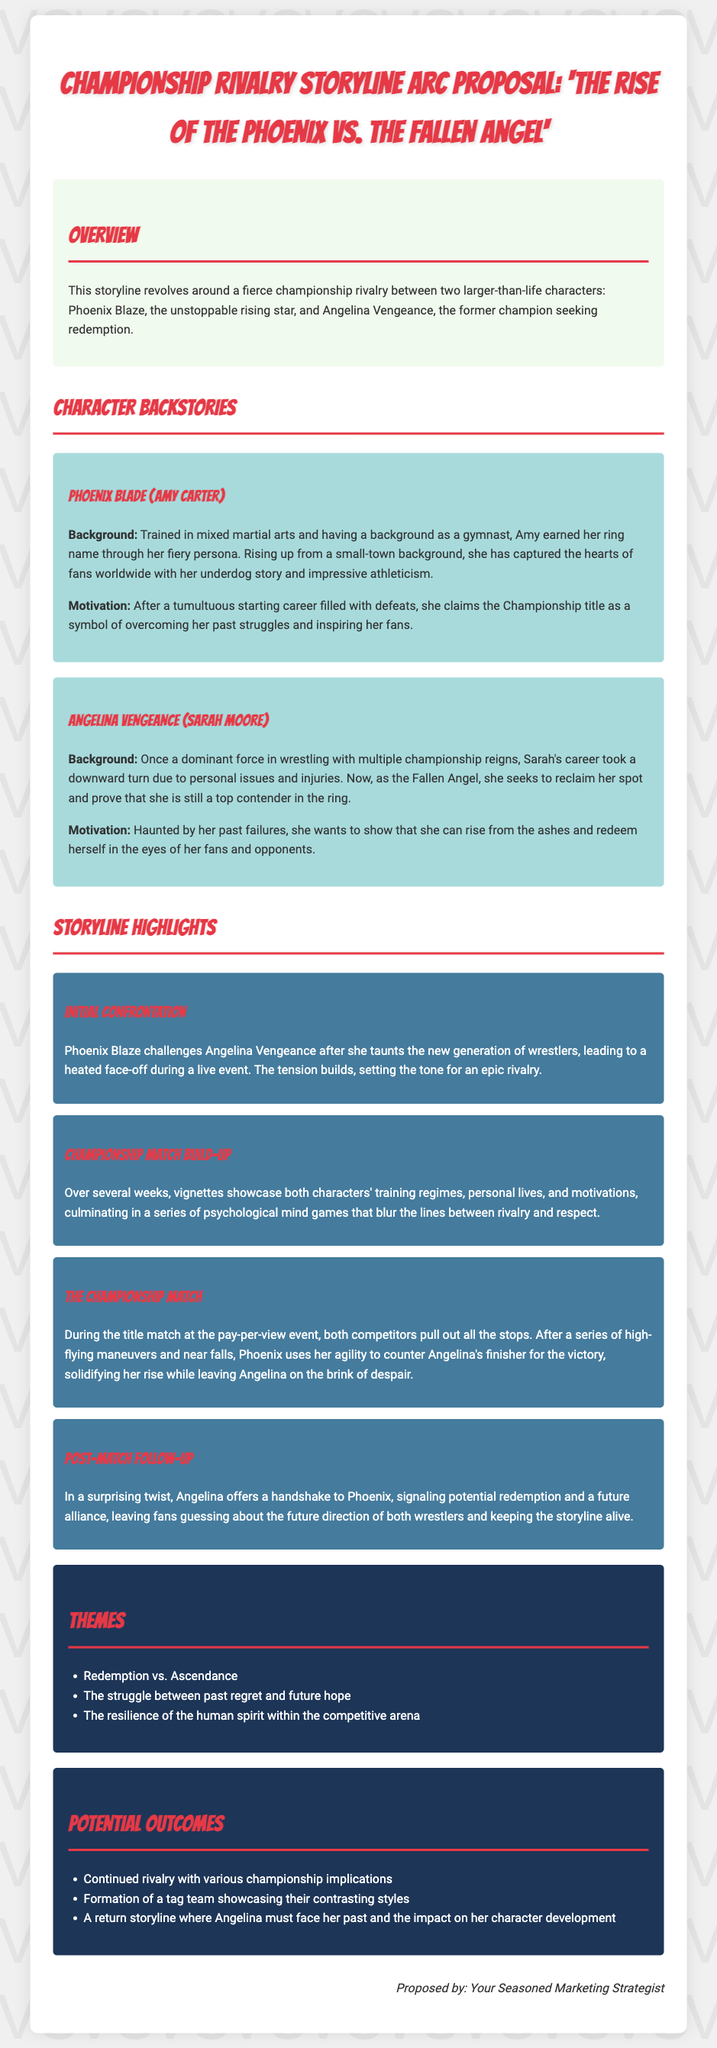What is the title of the proposal? The title of the proposal is given at the top of the document.
Answer: 'The Rise of the Phoenix vs. The Fallen Angel' Who is Phoenix Blaze's real name? The document provides the real name of Phoenix Blaze in the character backstory section.
Answer: Amy Carter What theme is associated with the storyline? The document lists several themes related to the storyline in the themes section.
Answer: Redemption vs. Ascendance Who offers a handshake in the post-match follow-up? The post-match follow-up describes a significant interaction between the two main characters.
Answer: Angelina During what event does the championship match take place? The document states the nature of the event where the championship match occurs.
Answer: Pay-per-view event What is the motivation of Angelina Vengeance? The character backstory section includes motivational details for Angelina Vengeance.
Answer: To reclaim her spot and prove she is still a top contender How many highlights are there in the storyline? The number of highlights can be counted in the storyline highlights section.
Answer: Four highlights What is the primary struggle depicted in the storyline? The themes section outlines the core struggle within the storyline.
Answer: Past regret and future hope 